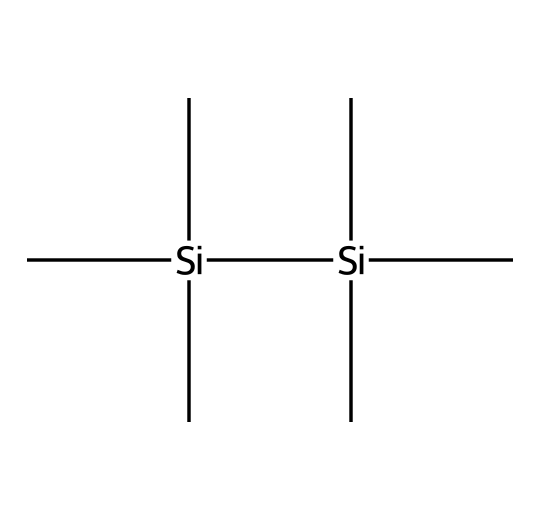What is the molecular formula of hexamethyldisilane? By analyzing the SMILES representation, we can count the number of carbon (C) and silicon (Si) atoms. There are a total of 6 carbon and 2 silicon atoms. Therefore, the molecular formula is C6H18Si2.
Answer: C6H18Si2 How many silicon atoms are present in hexamethyldisilane? The number of silicon atoms can be directly inferred from the SMILES, which shows two instances of 'Si'. Thus, there are 2 silicon atoms in the structure.
Answer: 2 What type of chemical compound is hexamethyldisilane? Hexamethyldisilane belongs to the family of silanes, which are silicon-containing compounds characterized by Si-H or Si-C bonds. The presence of silicon and carbon atoms indicates that it is indeed a silane.
Answer: silane How many bonds are formed between the silicon atoms in hexamethyldisilane? The SMILES shows the silicon atoms are connected to carbon atoms, but there is no indication of a direct bond between the silicon atoms themselves; therefore, they do not form a bond with each other.
Answer: 0 What is the hybridization state of the silicon atoms in hexamethyldisilane? Each silicon atom in hexamethyldisilane is bonded to three methyl groups and one silicon atom, leading to a tetrahedral geometry, which corresponds to sp3 hybridization for each silicon atom.
Answer: sp3 Which functional groups are present in hexamethyldisilane? The structure mainly consists of silicon and carbon atoms. The methyl groups (C) bonded to silicon represent alkyl functional groups derived from the presence of carbon. Since there are no characteristic functional groups like -OH or -NH2, it mainly has alkyl groups.
Answer: alkyl groups 